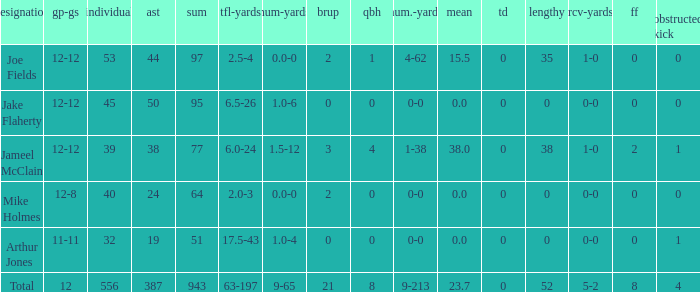How many players named jake flaherty? 1.0. 